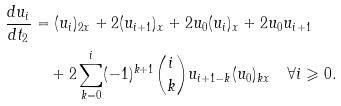<formula> <loc_0><loc_0><loc_500><loc_500>\frac { d u _ { i } } { d t _ { 2 } } & = ( u _ { i } ) _ { 2 x } + 2 ( u _ { i + 1 } ) _ { x } + 2 u _ { 0 } ( u _ { i } ) _ { x } + 2 u _ { 0 } u _ { i + 1 } \\ & \quad + 2 \sum _ { k = 0 } ^ { i } ( - 1 ) ^ { k + 1 } \binom { i } { k } u _ { i + 1 - k } ( u _ { 0 } ) _ { k x } \quad \forall i \geqslant 0 .</formula> 